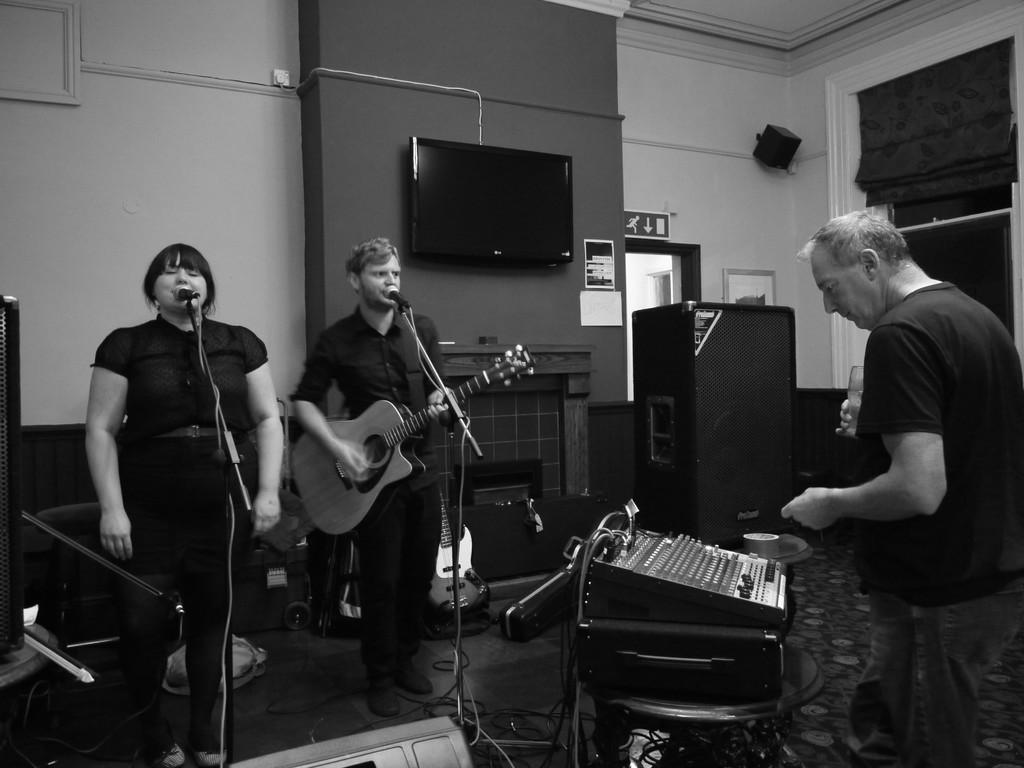How many people are present in the image? There are three people in the image. Where are the people located? The people are in a room. What are the people doing in the image? The people are standing and playing a musical instrument. What type of tongue can be seen playing a musical instrument in the image? There is no tongue present in the image, and tongues cannot play musical instruments. 